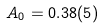<formula> <loc_0><loc_0><loc_500><loc_500>A _ { 0 } = 0 . 3 8 ( 5 )</formula> 